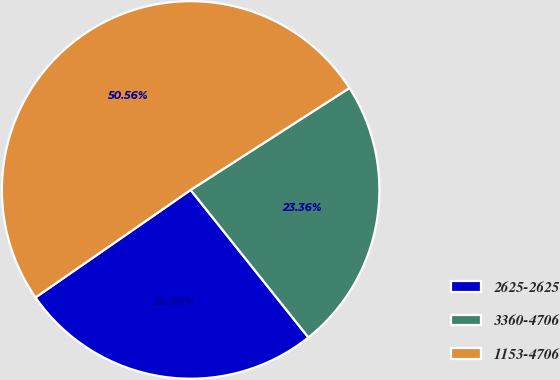<chart> <loc_0><loc_0><loc_500><loc_500><pie_chart><fcel>2625-2625<fcel>3360-4706<fcel>1153-4706<nl><fcel>26.08%<fcel>23.36%<fcel>50.57%<nl></chart> 